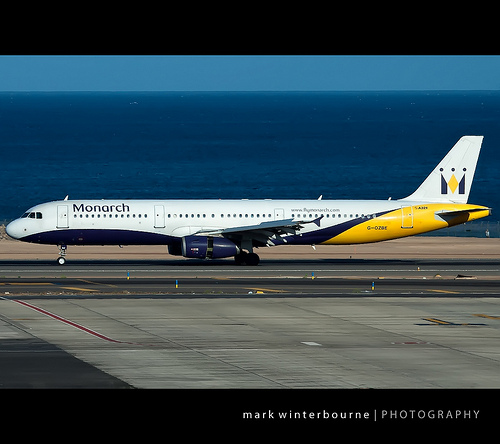Please provide a short description for this region: [0.8, 0.32, 0.97, 0.46]. The tail section of a commercial jet, displaying part of the vertical stabilizer and the airline's livery. 